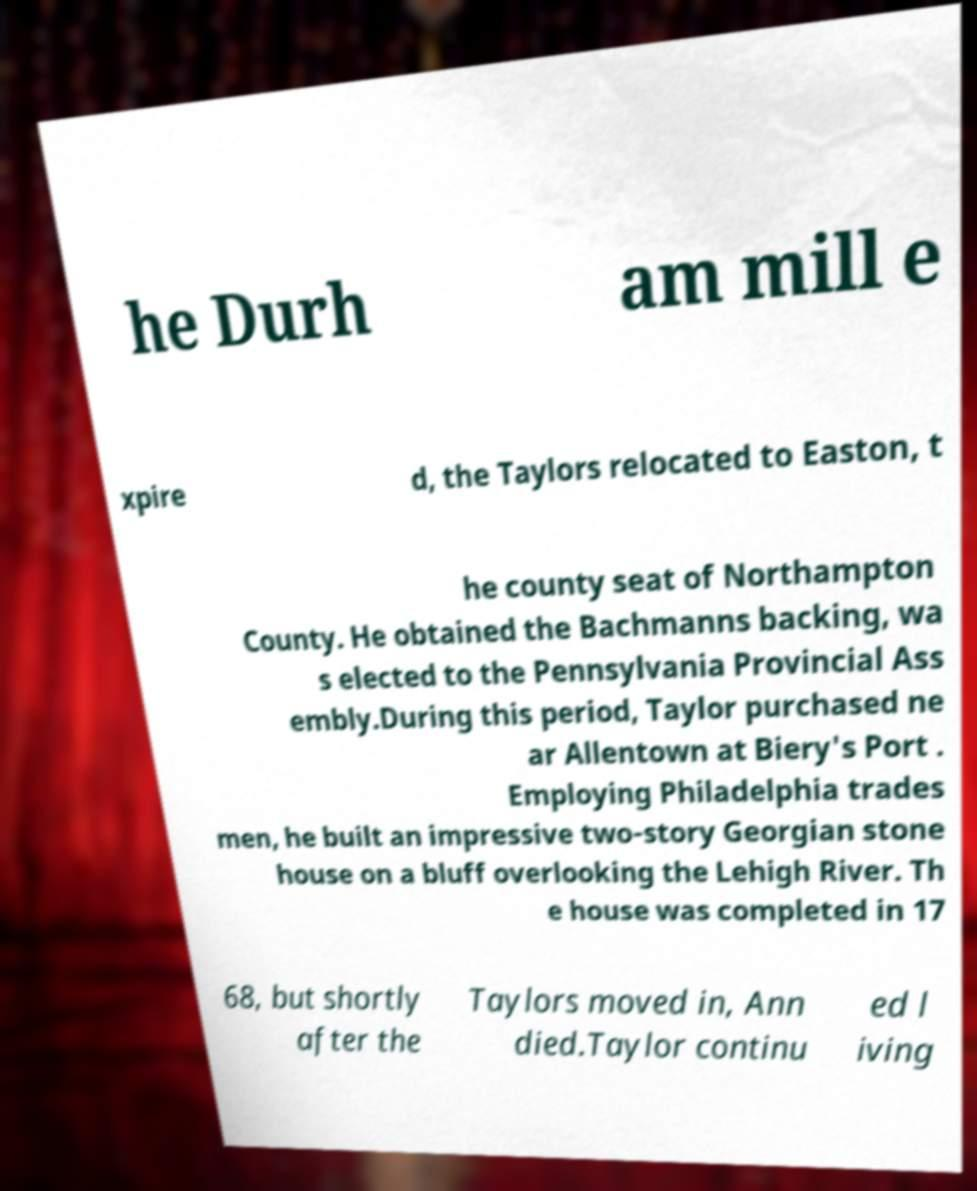Please identify and transcribe the text found in this image. he Durh am mill e xpire d, the Taylors relocated to Easton, t he county seat of Northampton County. He obtained the Bachmanns backing, wa s elected to the Pennsylvania Provincial Ass embly.During this period, Taylor purchased ne ar Allentown at Biery's Port . Employing Philadelphia trades men, he built an impressive two-story Georgian stone house on a bluff overlooking the Lehigh River. Th e house was completed in 17 68, but shortly after the Taylors moved in, Ann died.Taylor continu ed l iving 